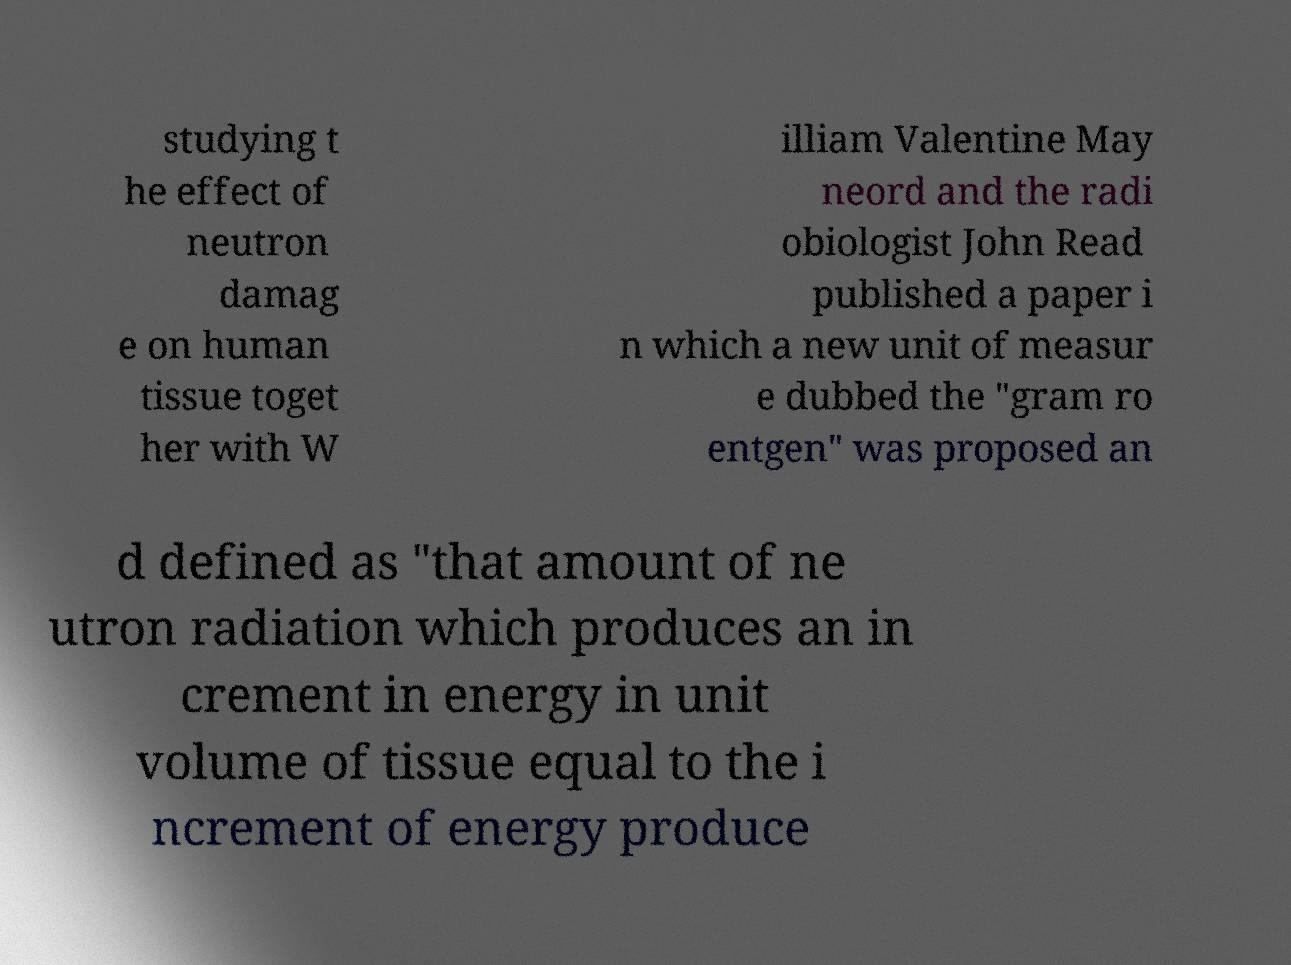What messages or text are displayed in this image? I need them in a readable, typed format. studying t he effect of neutron damag e on human tissue toget her with W illiam Valentine May neord and the radi obiologist John Read published a paper i n which a new unit of measur e dubbed the "gram ro entgen" was proposed an d defined as "that amount of ne utron radiation which produces an in crement in energy in unit volume of tissue equal to the i ncrement of energy produce 